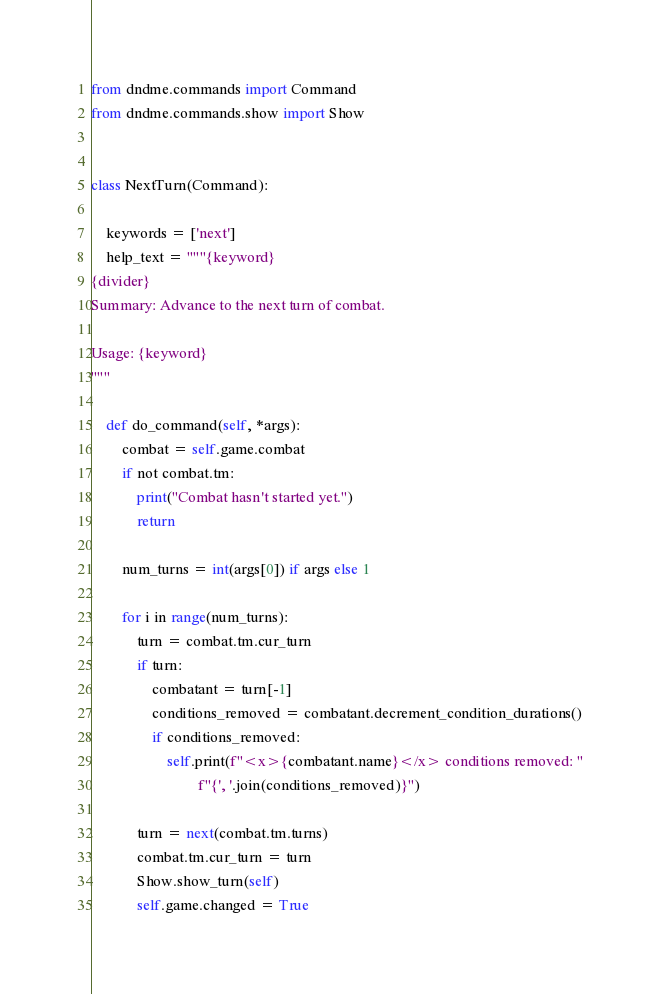Convert code to text. <code><loc_0><loc_0><loc_500><loc_500><_Python_>from dndme.commands import Command
from dndme.commands.show import Show


class NextTurn(Command):

    keywords = ['next']
    help_text = """{keyword}
{divider}
Summary: Advance to the next turn of combat.

Usage: {keyword}
"""

    def do_command(self, *args):
        combat = self.game.combat
        if not combat.tm:
            print("Combat hasn't started yet.")
            return

        num_turns = int(args[0]) if args else 1

        for i in range(num_turns):
            turn = combat.tm.cur_turn
            if turn:
                combatant = turn[-1]
                conditions_removed = combatant.decrement_condition_durations()
                if conditions_removed:
                    self.print(f"<x>{combatant.name}</x> conditions removed: "
                            f"{', '.join(conditions_removed)}")

            turn = next(combat.tm.turns)
            combat.tm.cur_turn = turn
            Show.show_turn(self)
            self.game.changed = True</code> 